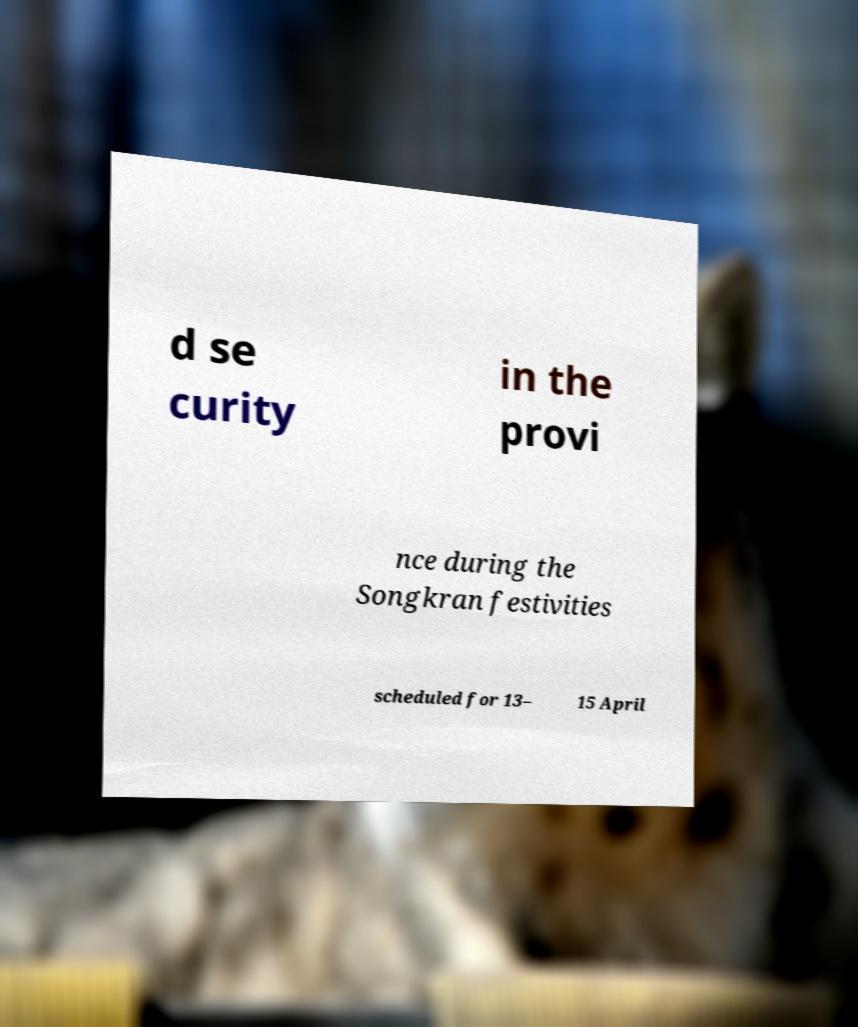Can you accurately transcribe the text from the provided image for me? d se curity in the provi nce during the Songkran festivities scheduled for 13– 15 April 